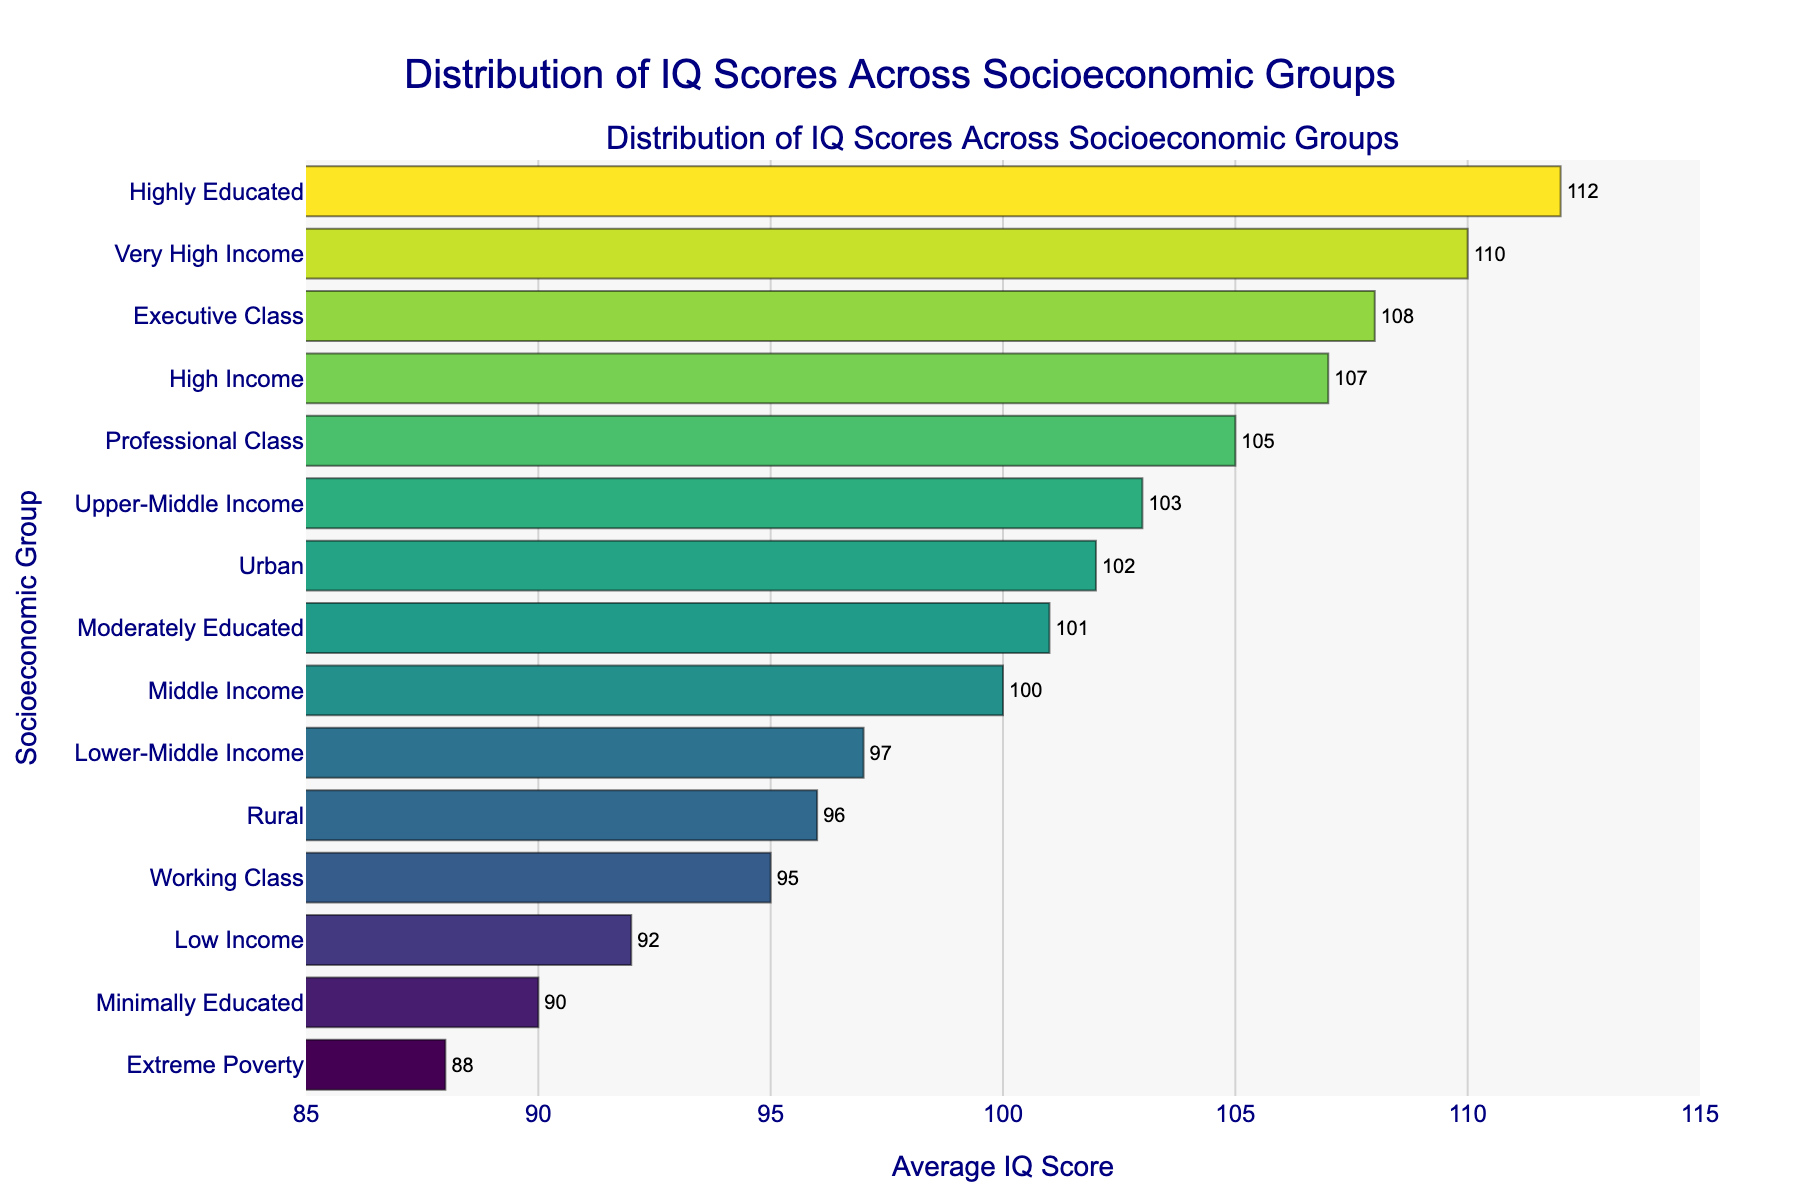Which socioeconomic group has the highest average IQ score? The highest bar represents the "Highly Educated" group with an average IQ score of 112.
Answer: Highly Educated Which group has a lower average IQ score, "Urban" or "Rural"? Comparing the heights of the bars, "Urban" has an average IQ score of 102 while "Rural" has an average IQ score of 96.
Answer: Rural What is the IQ score range (difference between highest and lowest average IQ scores) across these socioeconomic groups? The "Highly Educated" group has the highest average IQ score of 112 and the "Extreme Poverty" group has the lowest average IQ score of 88. The range is 112 - 88 = 24.
Answer: 24 How much higher is the average IQ score of the "High Income" group compared to the "Low Income" group? The "High Income" group has an average IQ score of 107 and the "Low Income" group has an average IQ score of 92. The difference is 107 - 92 = 15.
Answer: 15 Which socioeconomic groups have average IQ scores greater than 105? Groups with bars extending beyond 105 on the x-axis are "Highly Educated" (112), "Very High Income" (110), "Executive Class" (108), "High Income" (107), and "Professional Class" (105).
Answer: Highly Educated, Very High Income, Executive Class, High Income, Professional Class What is the median average IQ score of these socioeconomic groups? To find the median, list the average IQ scores in ascending order: 88, 90, 92, 95, 96, 97, 100, 101, 102, 103, 105, 107, 108, 110, 112. The middle value (8th value) is 101.
Answer: 101 Between "Working Class" and "Professional Class," which group's bar is longer and by how much? The "Professional Class" group has an average IQ score of 105, while the "Working Class" group has an average IQ score of 95. The difference is 105 - 95 = 10.
Answer: Professional Class; 10 How many socioeconomic groups have average IQ scores below the overall mean of 100? Groups with average IQ scores below 100 are "Extreme Poverty" (88), "Minimally Educated" (90), "Low Income" (92), "Working Class" (95), "Rural" (96), and "Lower-Middle Income" (97). There are 6 groups.
Answer: 6 